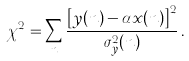<formula> <loc_0><loc_0><loc_500><loc_500>\chi ^ { 2 } = \sum _ { n } \frac { \left [ y ( n ) - \alpha x ( n ) \right ] ^ { 2 } } { \sigma ^ { 2 } _ { y } ( n ) } \, .</formula> 